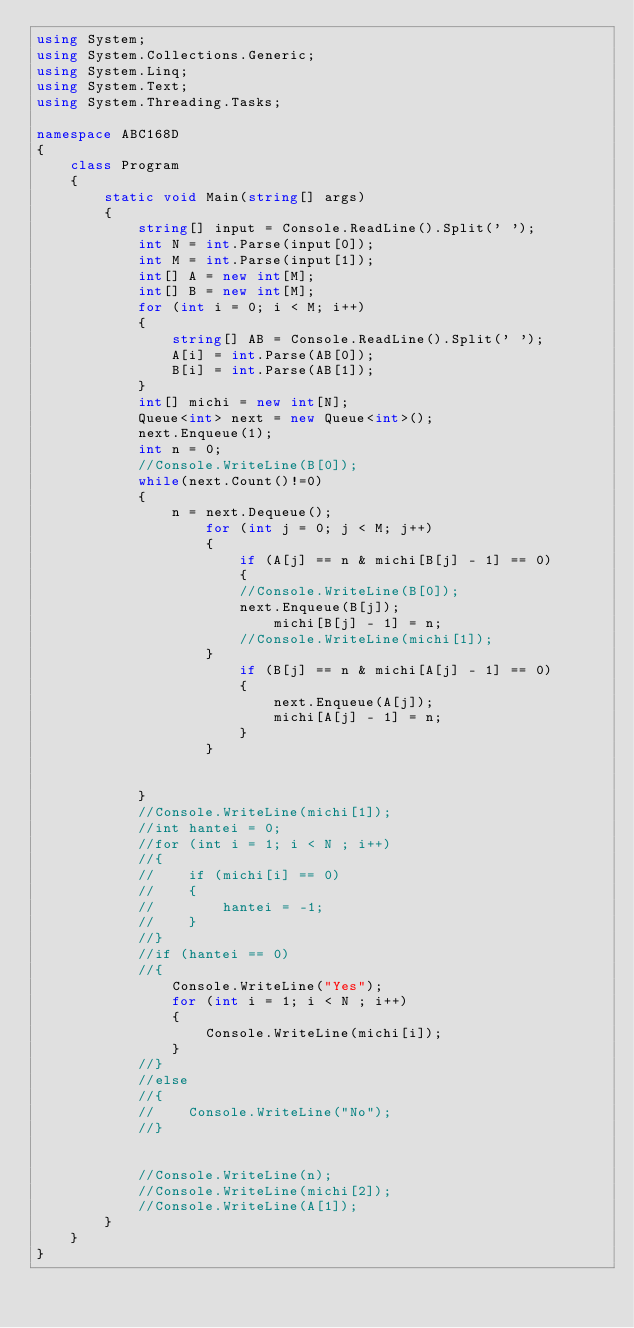Convert code to text. <code><loc_0><loc_0><loc_500><loc_500><_C#_>using System;
using System.Collections.Generic;
using System.Linq;
using System.Text;
using System.Threading.Tasks;

namespace ABC168D
{
    class Program
    {
        static void Main(string[] args)
        {
            string[] input = Console.ReadLine().Split(' ');
            int N = int.Parse(input[0]);
            int M = int.Parse(input[1]);
            int[] A = new int[M];
            int[] B = new int[M];
            for (int i = 0; i < M; i++)
            {
                string[] AB = Console.ReadLine().Split(' ');
                A[i] = int.Parse(AB[0]);
                B[i] = int.Parse(AB[1]);
            }
            int[] michi = new int[N];
            Queue<int> next = new Queue<int>();
            next.Enqueue(1);
            int n = 0;
            //Console.WriteLine(B[0]);
            while(next.Count()!=0)
            {
                n = next.Dequeue();
                    for (int j = 0; j < M; j++)
                    {
                        if (A[j] == n & michi[B[j] - 1] == 0)
                        {
                        //Console.WriteLine(B[0]);
                        next.Enqueue(B[j]);
                            michi[B[j] - 1] = n;
                        //Console.WriteLine(michi[1]);
                    }
                        if (B[j] == n & michi[A[j] - 1] == 0)
                        {
                            next.Enqueue(A[j]);
                            michi[A[j] - 1] = n;
                        }
                    }
                
                
            }
            //Console.WriteLine(michi[1]);
            //int hantei = 0;
            //for (int i = 1; i < N ; i++)
            //{
            //    if (michi[i] == 0)
            //    {
            //        hantei = -1;
            //    }
            //}
            //if (hantei == 0)
            //{
                Console.WriteLine("Yes");
                for (int i = 1; i < N ; i++)
                {
                    Console.WriteLine(michi[i]);
                }
            //}
            //else
            //{
            //    Console.WriteLine("No");
            //}
            

            //Console.WriteLine(n);
            //Console.WriteLine(michi[2]);
            //Console.WriteLine(A[1]);
        }
    }
}
</code> 